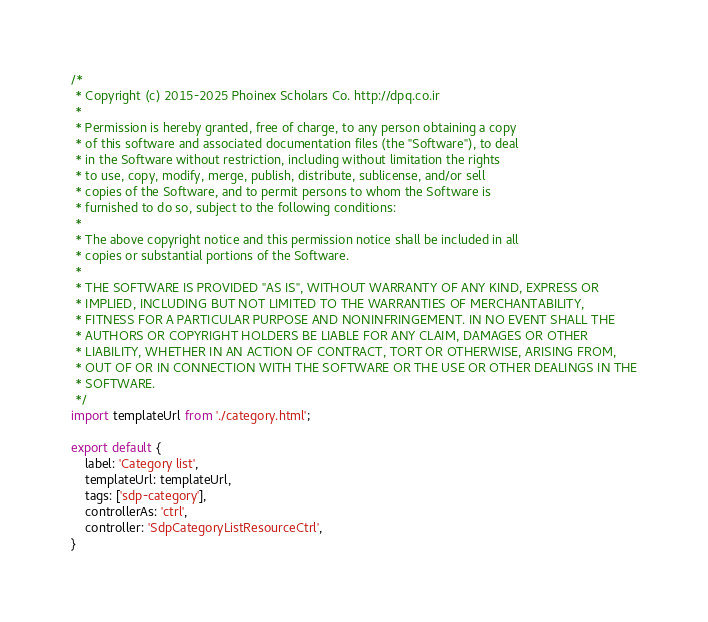Convert code to text. <code><loc_0><loc_0><loc_500><loc_500><_JavaScript_>/*
 * Copyright (c) 2015-2025 Phoinex Scholars Co. http://dpq.co.ir
 * 
 * Permission is hereby granted, free of charge, to any person obtaining a copy
 * of this software and associated documentation files (the "Software"), to deal
 * in the Software without restriction, including without limitation the rights
 * to use, copy, modify, merge, publish, distribute, sublicense, and/or sell
 * copies of the Software, and to permit persons to whom the Software is
 * furnished to do so, subject to the following conditions:
 * 
 * The above copyright notice and this permission notice shall be included in all
 * copies or substantial portions of the Software.
 * 
 * THE SOFTWARE IS PROVIDED "AS IS", WITHOUT WARRANTY OF ANY KIND, EXPRESS OR
 * IMPLIED, INCLUDING BUT NOT LIMITED TO THE WARRANTIES OF MERCHANTABILITY,
 * FITNESS FOR A PARTICULAR PURPOSE AND NONINFRINGEMENT. IN NO EVENT SHALL THE
 * AUTHORS OR COPYRIGHT HOLDERS BE LIABLE FOR ANY CLAIM, DAMAGES OR OTHER
 * LIABILITY, WHETHER IN AN ACTION OF CONTRACT, TORT OR OTHERWISE, ARISING FROM,
 * OUT OF OR IN CONNECTION WITH THE SOFTWARE OR THE USE OR OTHER DEALINGS IN THE
 * SOFTWARE.
 */
import templateUrl from './category.html';

export default {
	label: 'Category list',
	templateUrl: templateUrl,
	tags: ['sdp-category'],
	controllerAs: 'ctrl',
	controller: 'SdpCategoryListResourceCtrl',
}

</code> 